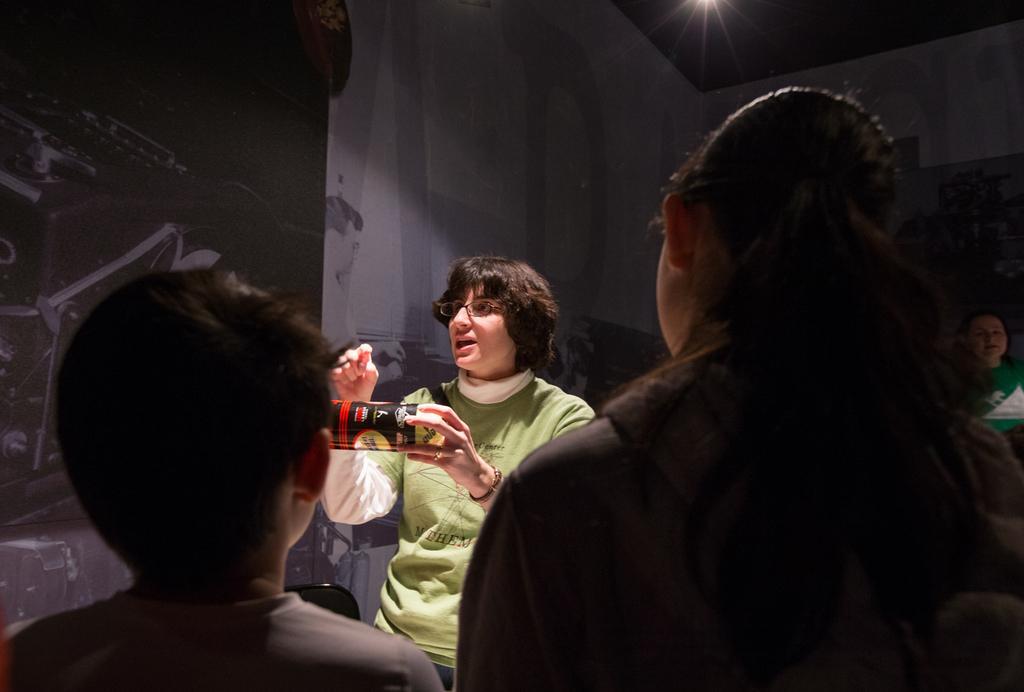How would you summarize this image in a sentence or two? In this image there are few people, one of them is holding an object and explaining something to others. In the background there is a wall with a poster on it. At the top of the image there is a ceiling and a light. 